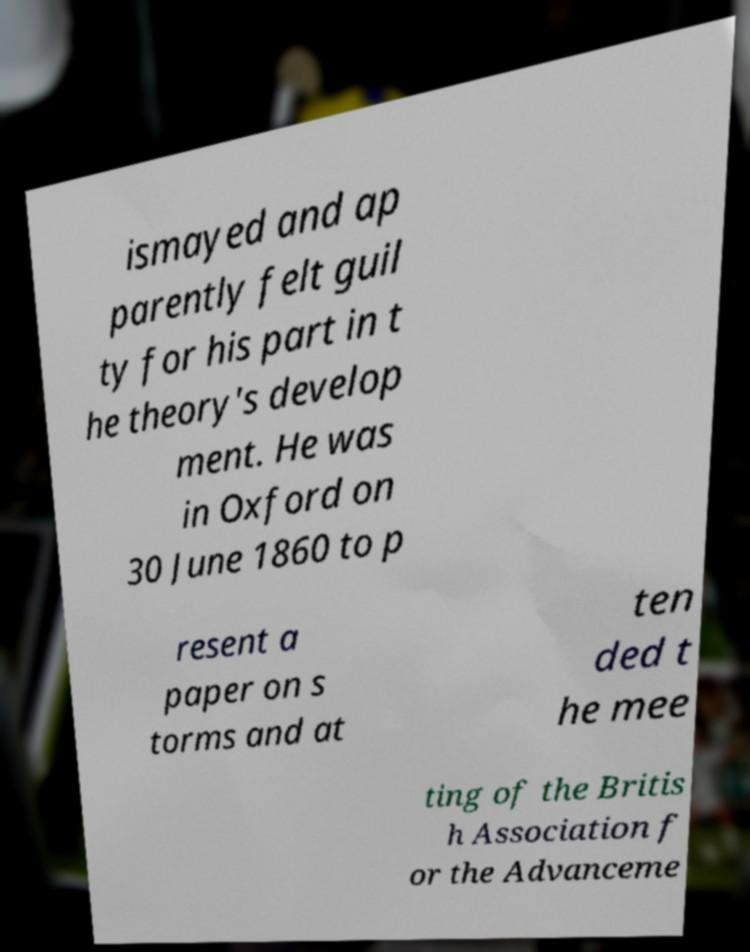Could you extract and type out the text from this image? ismayed and ap parently felt guil ty for his part in t he theory's develop ment. He was in Oxford on 30 June 1860 to p resent a paper on s torms and at ten ded t he mee ting of the Britis h Association f or the Advanceme 